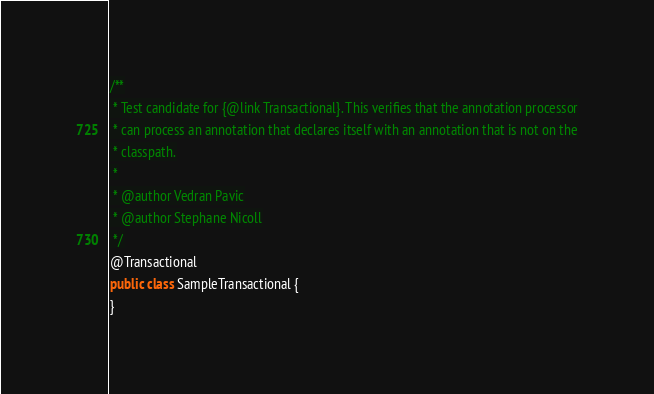<code> <loc_0><loc_0><loc_500><loc_500><_Java_>/**
 * Test candidate for {@link Transactional}. This verifies that the annotation processor
 * can process an annotation that declares itself with an annotation that is not on the
 * classpath.
 *
 * @author Vedran Pavic
 * @author Stephane Nicoll
 */
@Transactional
public class SampleTransactional {
}
</code> 